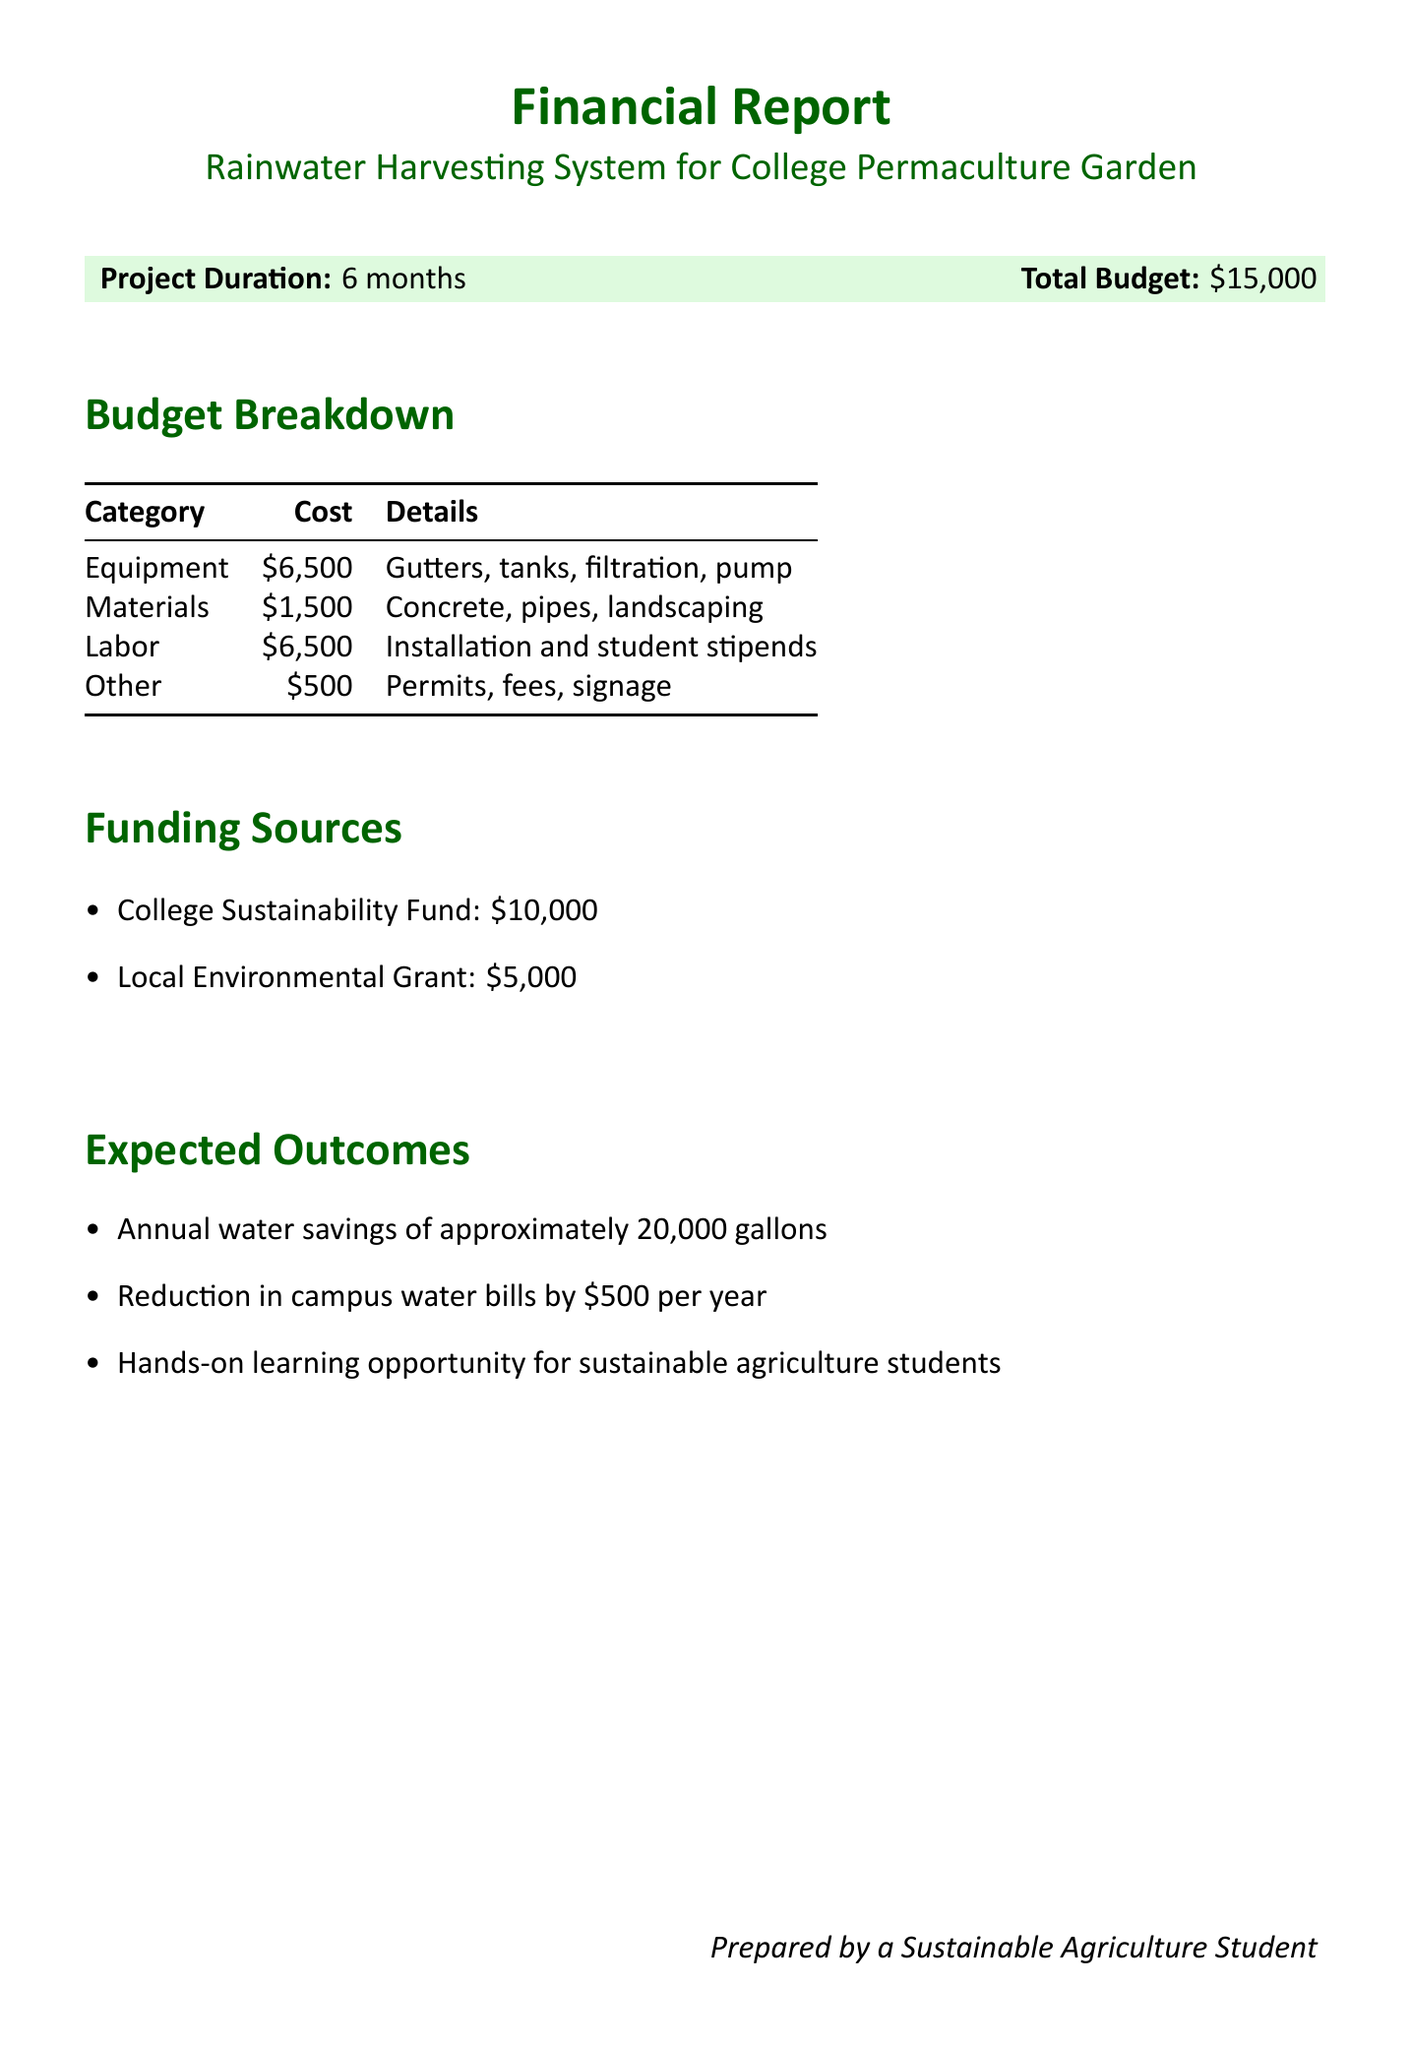What is the project title? The project title is stated clearly at the beginning of the document.
Answer: Rainwater Harvesting System for College Permaculture Garden What is the total budget for the project? The total budget is listed in the project details section.
Answer: $15,000 How many hours of installation labor are required? Installation labor is described in the labor budget breakdown section, which specifies hours.
Answer: 80 hours What is the cost of the storage tanks? The cost for storage tanks is detailed in the equipment section of the budget breakdown.
Answer: $3,000 What is the funding amount from the College Sustainability Fund? The funding sources section specifies the amount from each source, including this one.
Answer: $10,000 What is one expected outcome of the project? Expected outcomes are listed in their own section of the document, detailing the benefits of the project.
Answer: Annual water savings of approximately 20,000 gallons What is the cost of educational signage? The budget breakdown includes costs for various items, including this one under the "Other" category.
Answer: $200 What is the total cost for Labor? The total labor cost is calculated from the items listed in the labor budget breakdown.
Answer: $6,500 How many students will receive stipends? The labor budget section specifies the number of student workers involved in the project.
Answer: 3 students 